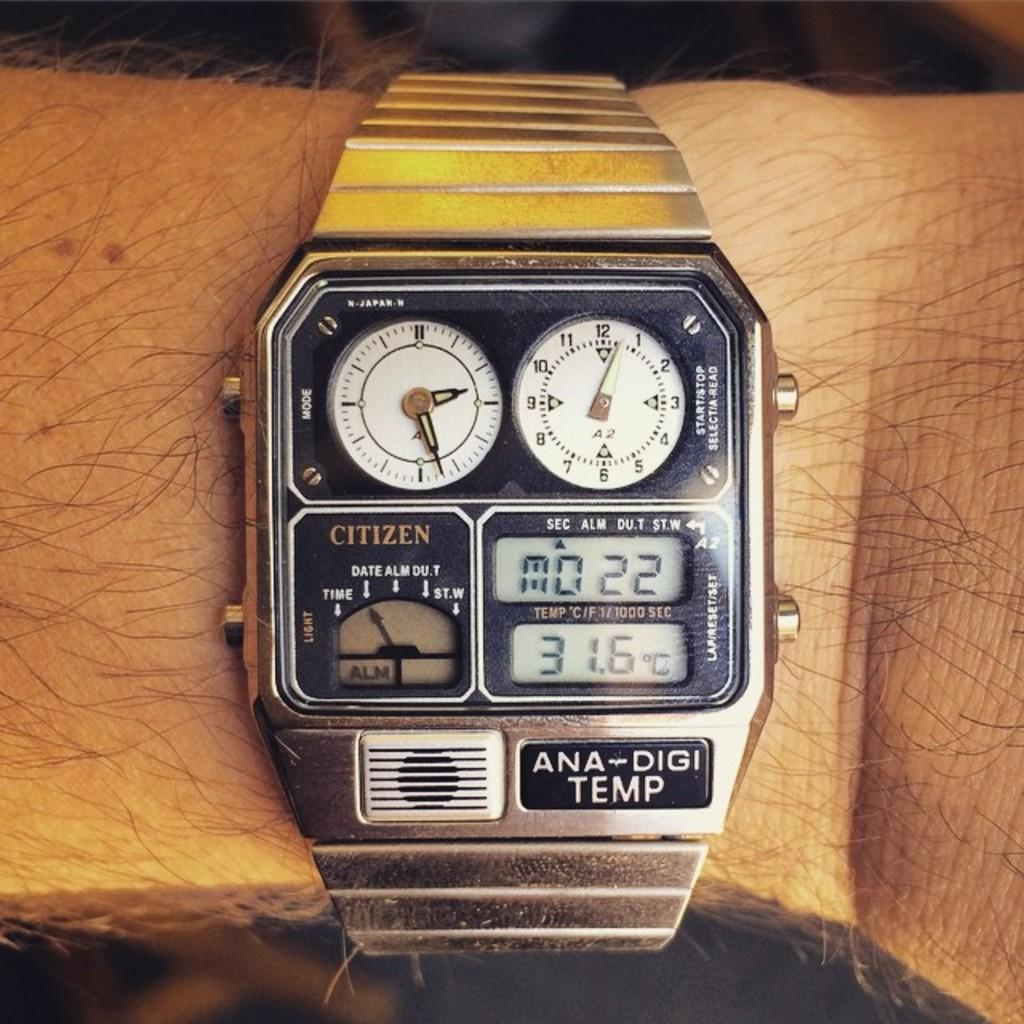Provide a one-sentence caption for the provided image. an old citizen watch has several faces on it. 